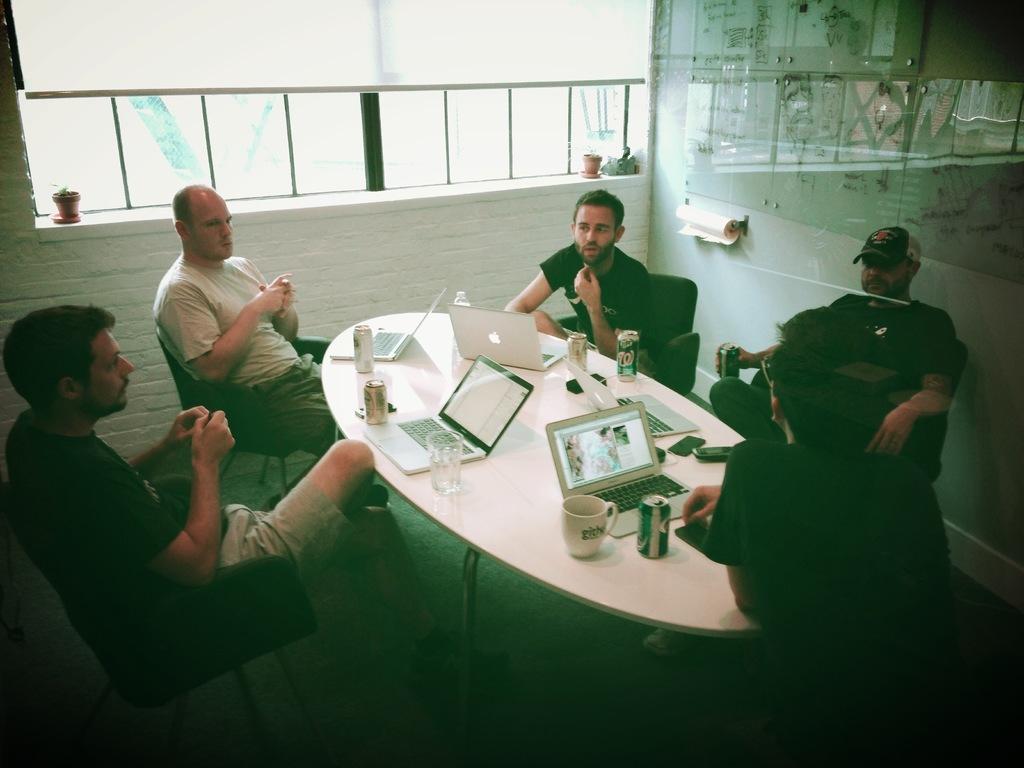Can you describe this image briefly? In the picture a group of men sitting on chairs around the table in a verandah. There are coffee mugs,soft drinks,laptops on the table. On right side wall there is tissue roll and glass sheet. 